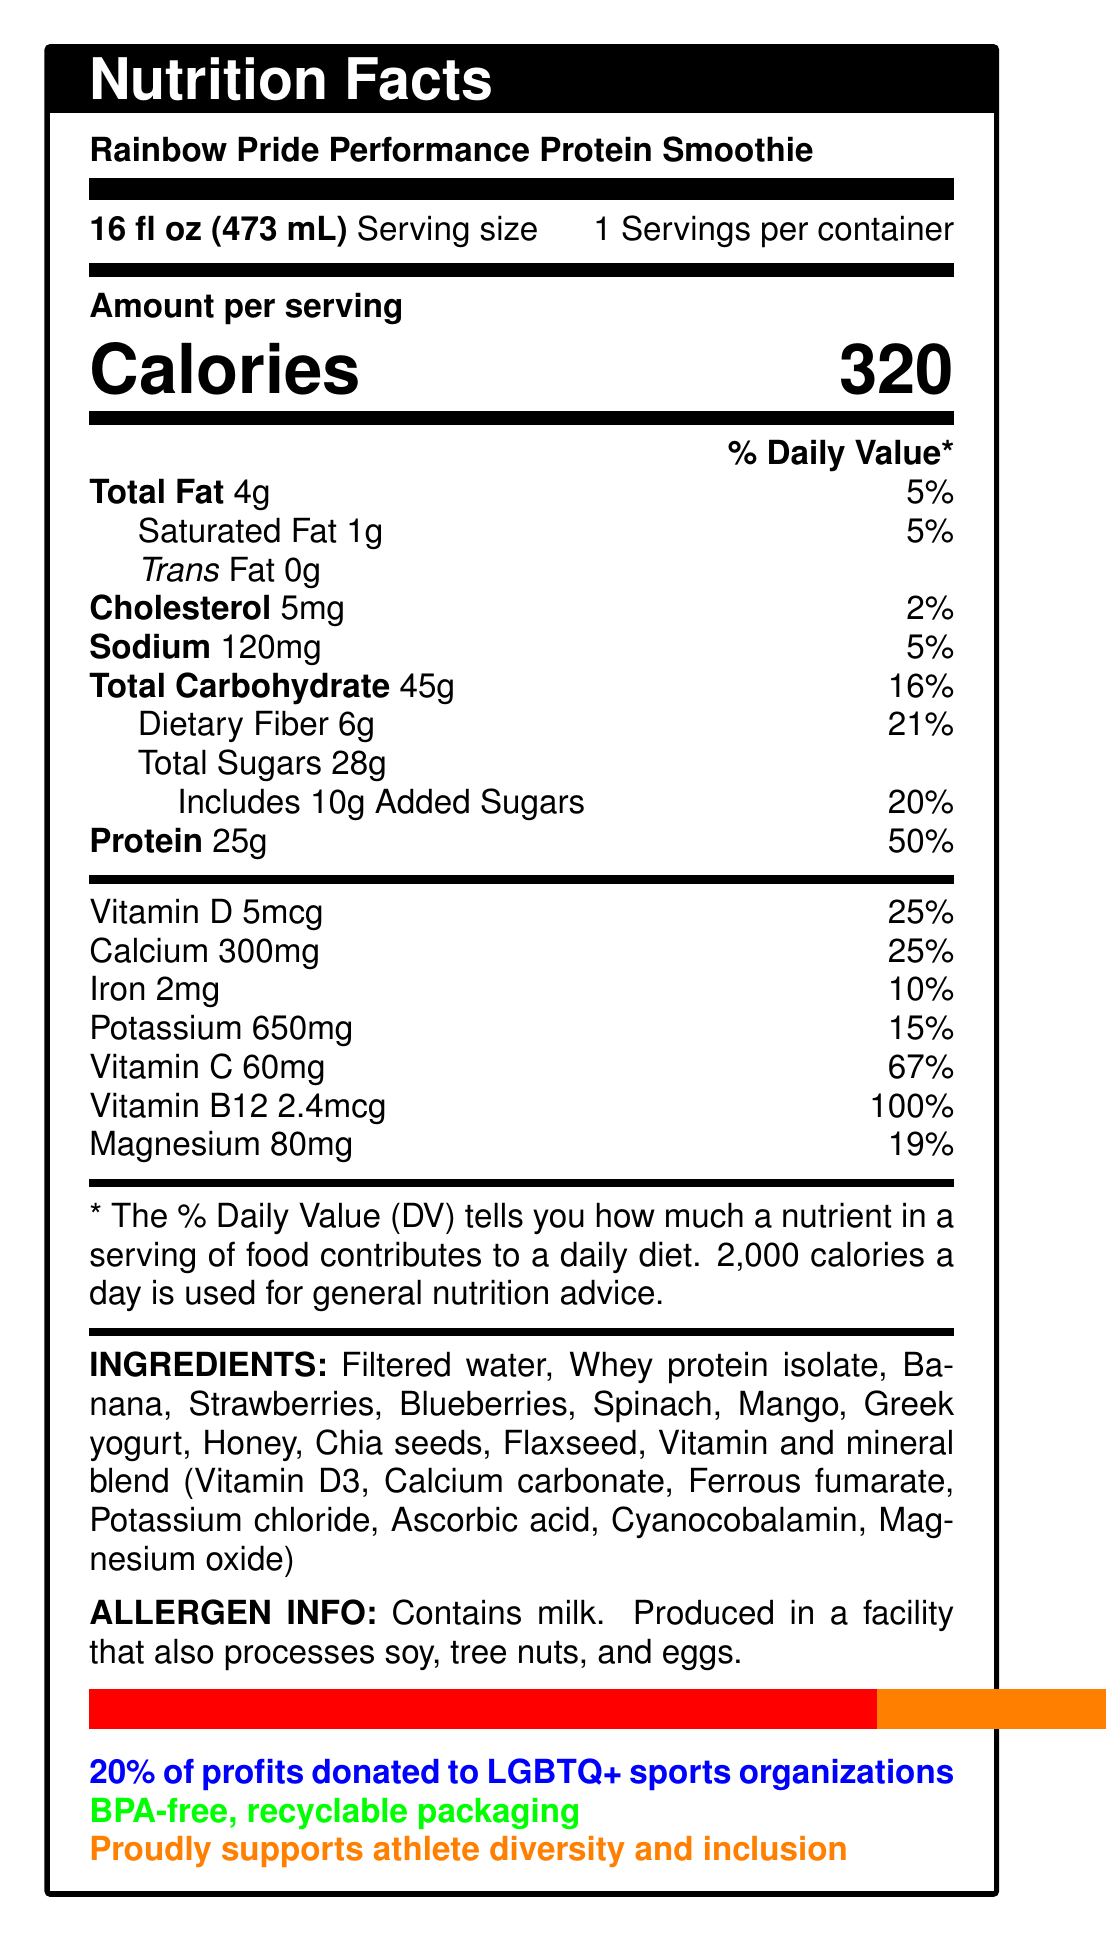what is the serving size? The serving size is stated directly in the label as 16 fl oz (473 mL).
Answer: 16 fl oz (473 mL) how many servings are in the container? The document specifies that there is 1 serving per container.
Answer: 1 how many calories does one serving contain? According to the label, one serving contains 320 calories.
Answer: 320 calories what is the total amount of protein per serving? The nutrition facts indicate that there are 25 grams of protein per serving.
Answer: 25g how much dietary fiber is in the smoothie? The label shows that the total dietary fiber content is 6 grams.
Answer: 6g how much calcium is in one serving? The calcium content per serving is listed as 300mg on the label.
Answer: 300mg how much of the smoothie is made up of sugars? The total amount of sugars in the smoothie is 28 grams.
Answer: 28g what percentage of the daily value of vitamin C does one serving provide? The label shows that one serving provides 67% of the daily value for vitamin C.
Answer: 67% does the smoothie contain any trans fat? The label indicates that there are 0 grams of trans fat in the smoothie.
Answer: No is the packaging environmentally friendly? The additional information section mentions that the packaging is BPA-free and recyclable.
Answer: Yes what allergies should consumers be aware of? The allergen info section specifies this.
Answer: Contains milk. Produced in a facility that also processes soy, tree nuts, and eggs. how much money is donated to LGBTQ+ sports organizations? A. 10% B. 15% C. 20% The additional info section specifies that 20% of profits are donated to LGBTQ+ sports organizations.
Answer: C which vitamin does the smoothie provide 100% of the daily value? A. Vitamin D B. Vitamin B12 C. Vitamin C The label indicates that Vitamin B12 provides 100% of the daily value in a serving.
Answer: B how many milligrams of sodium are in one serving? The sodium content per serving is listed as 120mg on the label.
Answer: 120mg does the product contain any peanuts? The allergen info does not mention peanuts, but it doesn't explicitly state that there are no peanuts either.
Answer: Not enough information what main idea or mission does the product promote? The product description and additional info sections indicate that the Rainbow Pride Performance Protein Smoothie supports athlete diversity, inclusion, and donates 20% of its profits to LGBTQ+ sports organizations.
Answer: The product promotes athlete diversity and inclusion and supports LGBTQ+ sports organizations. describe the ingredients blend in this smoothie. The ingredients section lists all the components used in the smoothie along with the vitamin and mineral blend components.
Answer: The smoothie contains a blend of filtered water, whey protein isolate, banana, strawberries, blueberries, spinach, mango, Greek yogurt, honey, chia seeds, flaxseed, and a vitamin and mineral blend. how much magnesium does each serving provide? The magnesium content per serving is listed as 80mg on the label.
Answer: 80mg 